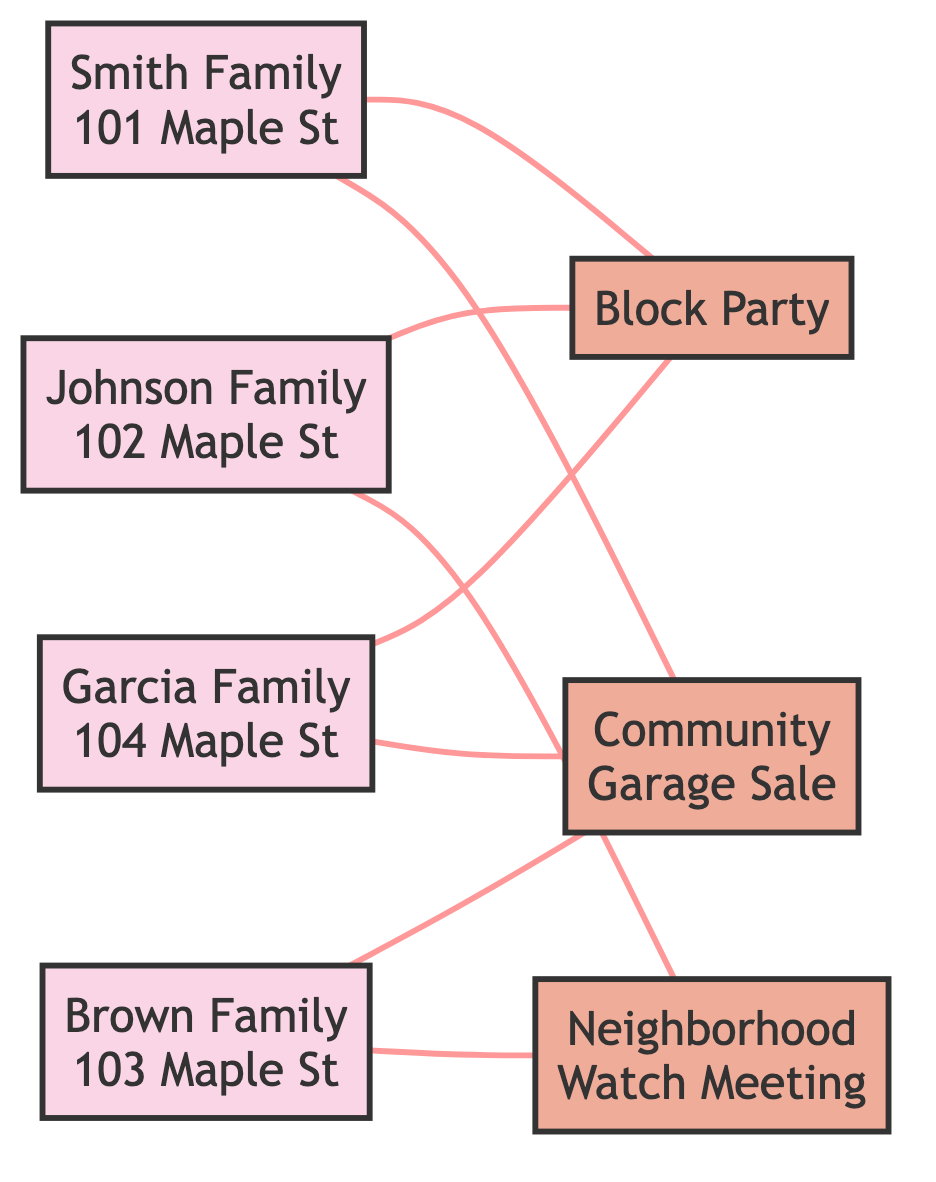What is the total number of households represented in the diagram? The diagram shows four households: Smith Family, Johnson Family, Brown Family, and Garcia Family. By counting each household node, we confirm there are a total of four households.
Answer: 4 Which neighborhood event is connected to the most households? By examining the edges, Block Party connects to three households: Smith Family, Johnson Family, and Garcia Family. Community Garage Sale connects to two households, and Neighborhood Watch Meeting connects to two households. Therefore, Block Party is connected to the most households.
Answer: Block Party How many events does the Brown Family participate in? The Brown Family is connected to two events in the diagram: Community Garage Sale and Neighborhood Watch Meeting. By looking at the edges from the Brown Family node, we see there are two connections.
Answer: 2 Which family participates in the Neighborhood Watch Meeting? The Neighborhood Watch Meeting is connected to the Johnson Family and the Brown Family. By examining the edges linked to this event, we identify both families as participants.
Answer: Johnson Family, Brown Family If Smith Family and Garcia Family both choose to attend the Block Party, what can we say about their total connections? Both the Smith Family and Garcia Family each have one connection to Block Party, meaning they are directly connected to the event. The total connections when they attend do not change; they each remain connected only to Block Party.
Answer: 2 